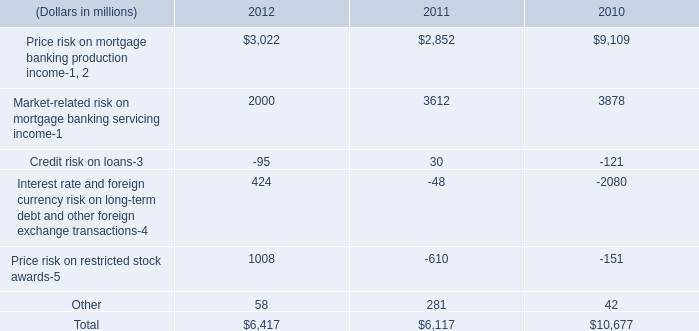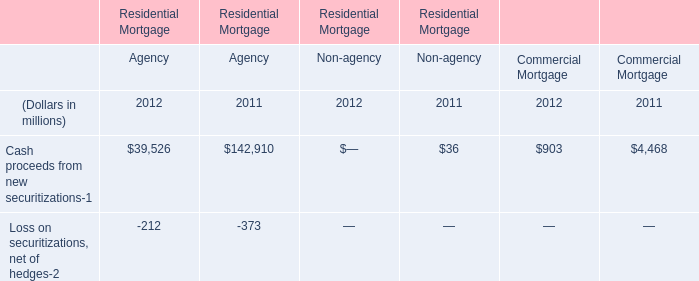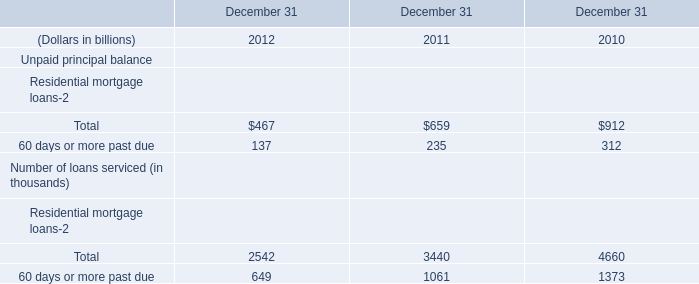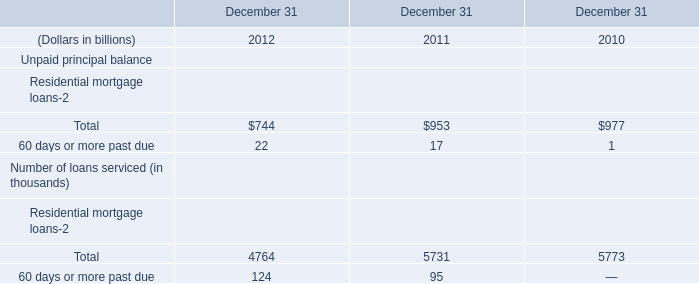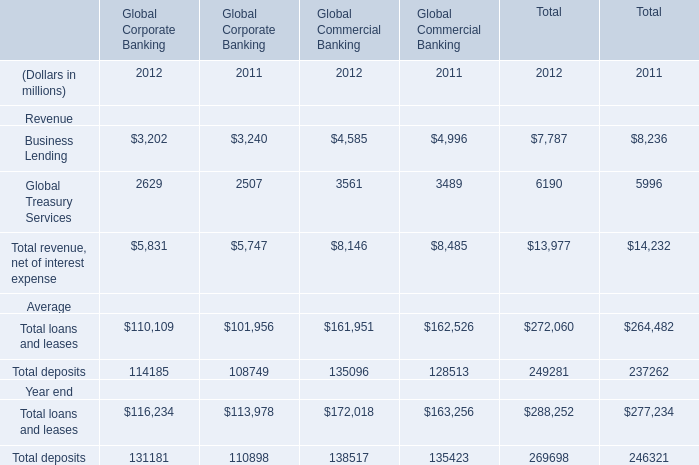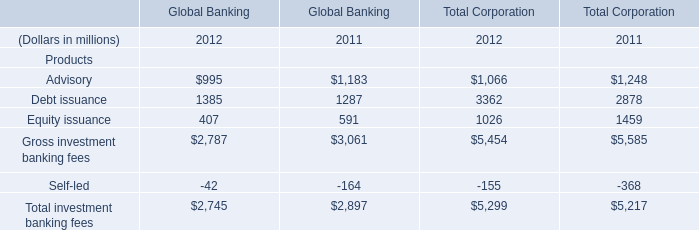What will Debt issuance of Global Banking be like in 2013 if it develops with the same increasing rate as current? (in dollars in millions) 
Computations: (1385 * (1 + ((1385 - 1287) / 1287)))
Answer: 1490.46232. 